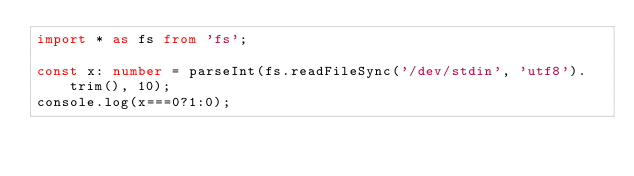Convert code to text. <code><loc_0><loc_0><loc_500><loc_500><_TypeScript_>import * as fs from 'fs';

const x: number = parseInt(fs.readFileSync('/dev/stdin', 'utf8').trim(), 10);
console.log(x===0?1:0);

</code> 